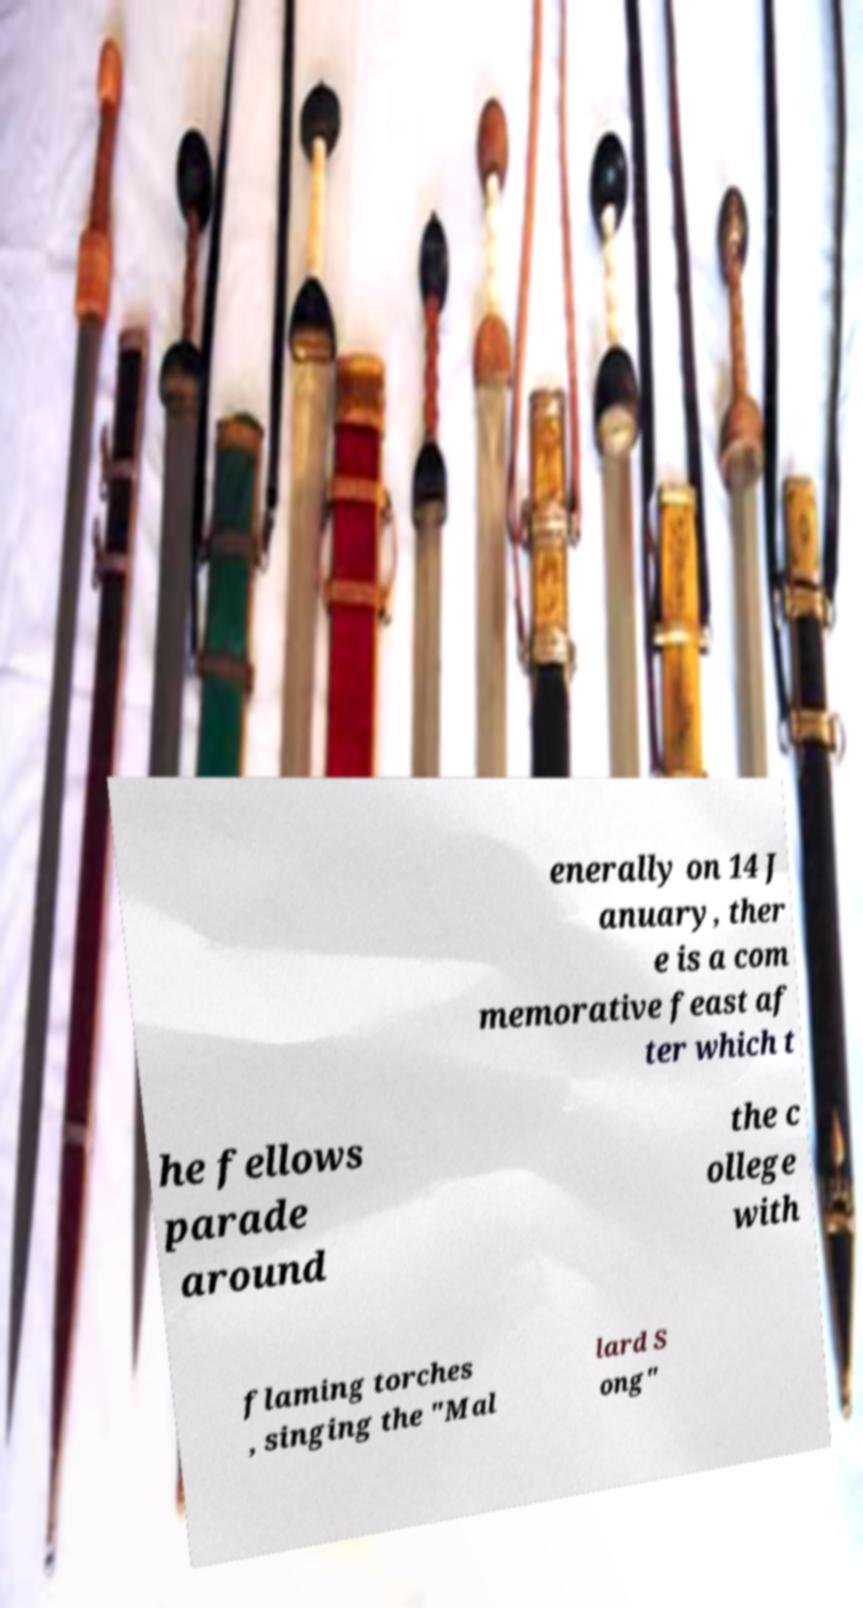Can you read and provide the text displayed in the image?This photo seems to have some interesting text. Can you extract and type it out for me? enerally on 14 J anuary, ther e is a com memorative feast af ter which t he fellows parade around the c ollege with flaming torches , singing the "Mal lard S ong" 